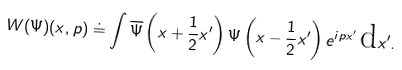<formula> <loc_0><loc_0><loc_500><loc_500>W ( \Psi ) ( x , p ) \doteq \int \overline { \Psi } \left ( x + \frac { 1 } { 2 } x ^ { \prime } \right ) \Psi \left ( x - \frac { 1 } { 2 } x ^ { \prime } \right ) e ^ { i p x ^ { \prime } } \, \text {d} x ^ { \prime } .</formula> 